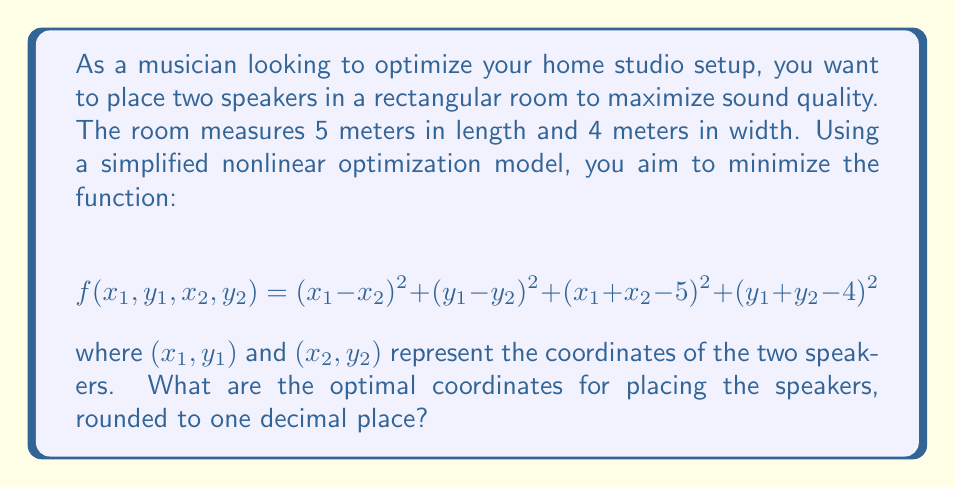Can you answer this question? To solve this problem, we'll use the following steps:

1) First, we need to understand what the function represents:
   - $(x_1 - x_2)^2 + (y_1 - y_2)^2$ aims to maximize the distance between speakers
   - $(x_1 + x_2 - 5)^2 + (y_1 + y_2 - 4)^2$ aims to center the speakers in the room

2) To find the minimum of this function, we need to find where its partial derivatives equal zero:

   $$\frac{\partial f}{\partial x_1} = 2(x_1 - x_2) + 2(x_1 + x_2 - 5) = 0$$
   $$\frac{\partial f}{\partial y_1} = 2(y_1 - y_2) + 2(y_1 + y_2 - 4) = 0$$
   $$\frac{\partial f}{\partial x_2} = -2(x_1 - x_2) + 2(x_1 + x_2 - 5) = 0$$
   $$\frac{\partial f}{\partial y_2} = -2(y_1 - y_2) + 2(y_1 + y_2 - 4) = 0$$

3) Simplifying these equations:

   $$4x_1 + 2x_2 = 10$$
   $$4y_1 + 2y_2 = 8$$
   $$2x_1 + 4x_2 = 10$$
   $$2y_1 + 4y_2 = 8$$

4) Solving this system of equations:

   From the first and third equations:
   $$x_1 = x_2 = 2.5$$

   From the second and fourth equations:
   $$y_1 = y_2 = 2$$

5) Therefore, the optimal coordinates are:
   $(x_1, y_1) = (2.5, 2)$ and $(x_2, y_2) = (2.5, 2)$

6) Rounding to one decimal place:
   $(x_1, y_1) = (2.5, 2.0)$ and $(x_2, y_2) = (2.5, 2.0)$

This solution places both speakers at the center of the room, which makes sense given our simplified model. In practice, you might want to add constraints to keep the speakers apart or consider more complex acoustic factors.
Answer: $(2.5, 2.0)$ and $(2.5, 2.0)$ 